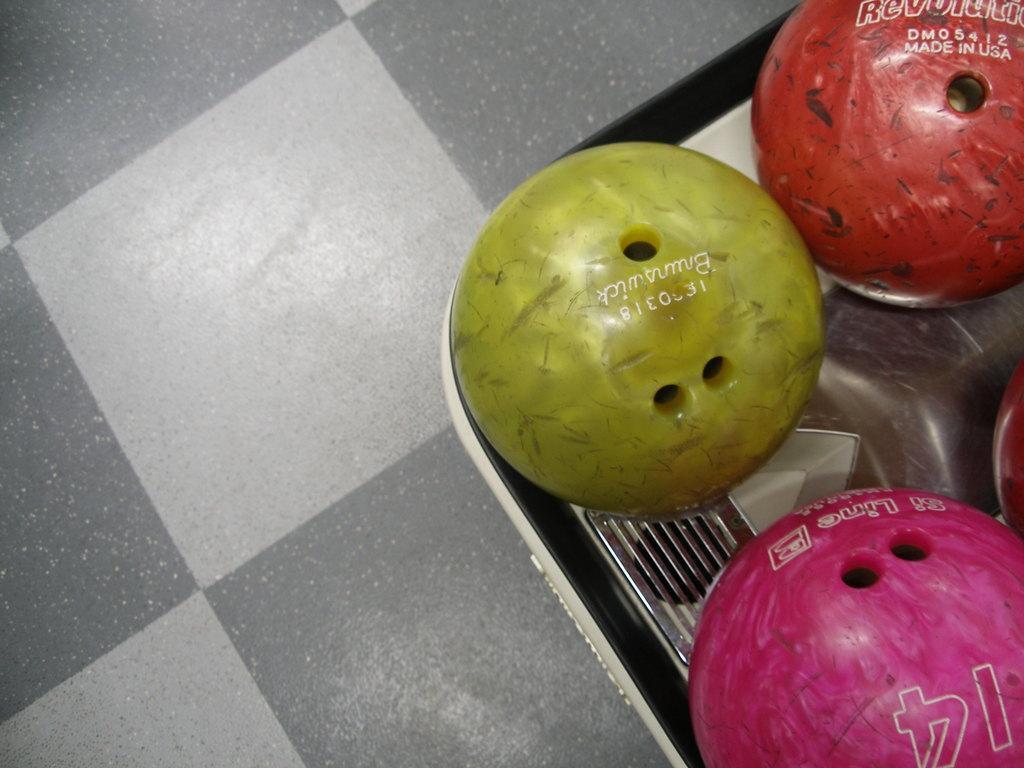How would you summarize this image in a sentence or two? In this picture I see the silver thing on which there are 3 balls which are of yellow, red and pink in color and I see something is written on these balls and on the left side of this image I see the floor. 